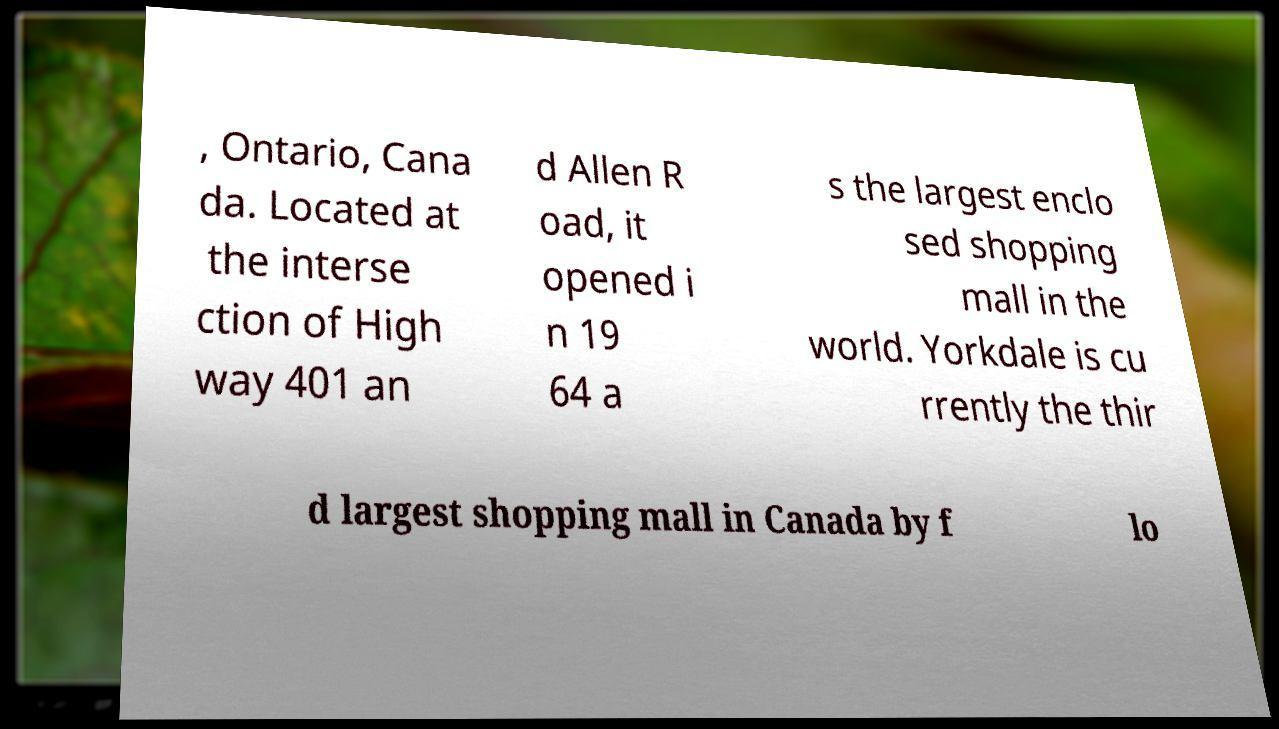I need the written content from this picture converted into text. Can you do that? , Ontario, Cana da. Located at the interse ction of High way 401 an d Allen R oad, it opened i n 19 64 a s the largest enclo sed shopping mall in the world. Yorkdale is cu rrently the thir d largest shopping mall in Canada by f lo 